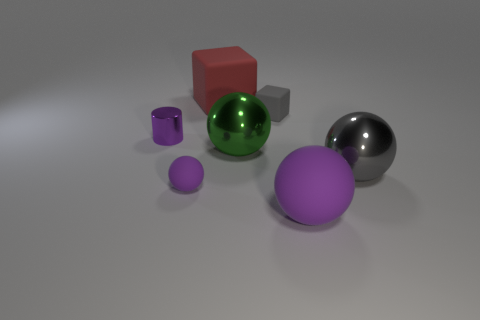How many objects are there, and can you describe their colors and shapes? There are six objects in total. Starting from the left, there's a small purple cylinder, a medium-sized purple sphere, a large green sphere with a reflective surface, a giant grey sphere, a small grey cube, and a medium-sized red cube. 